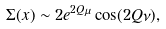Convert formula to latex. <formula><loc_0><loc_0><loc_500><loc_500>\Sigma ( x ) \sim 2 e ^ { 2 Q \mu } \cos ( 2 Q \nu ) ,</formula> 